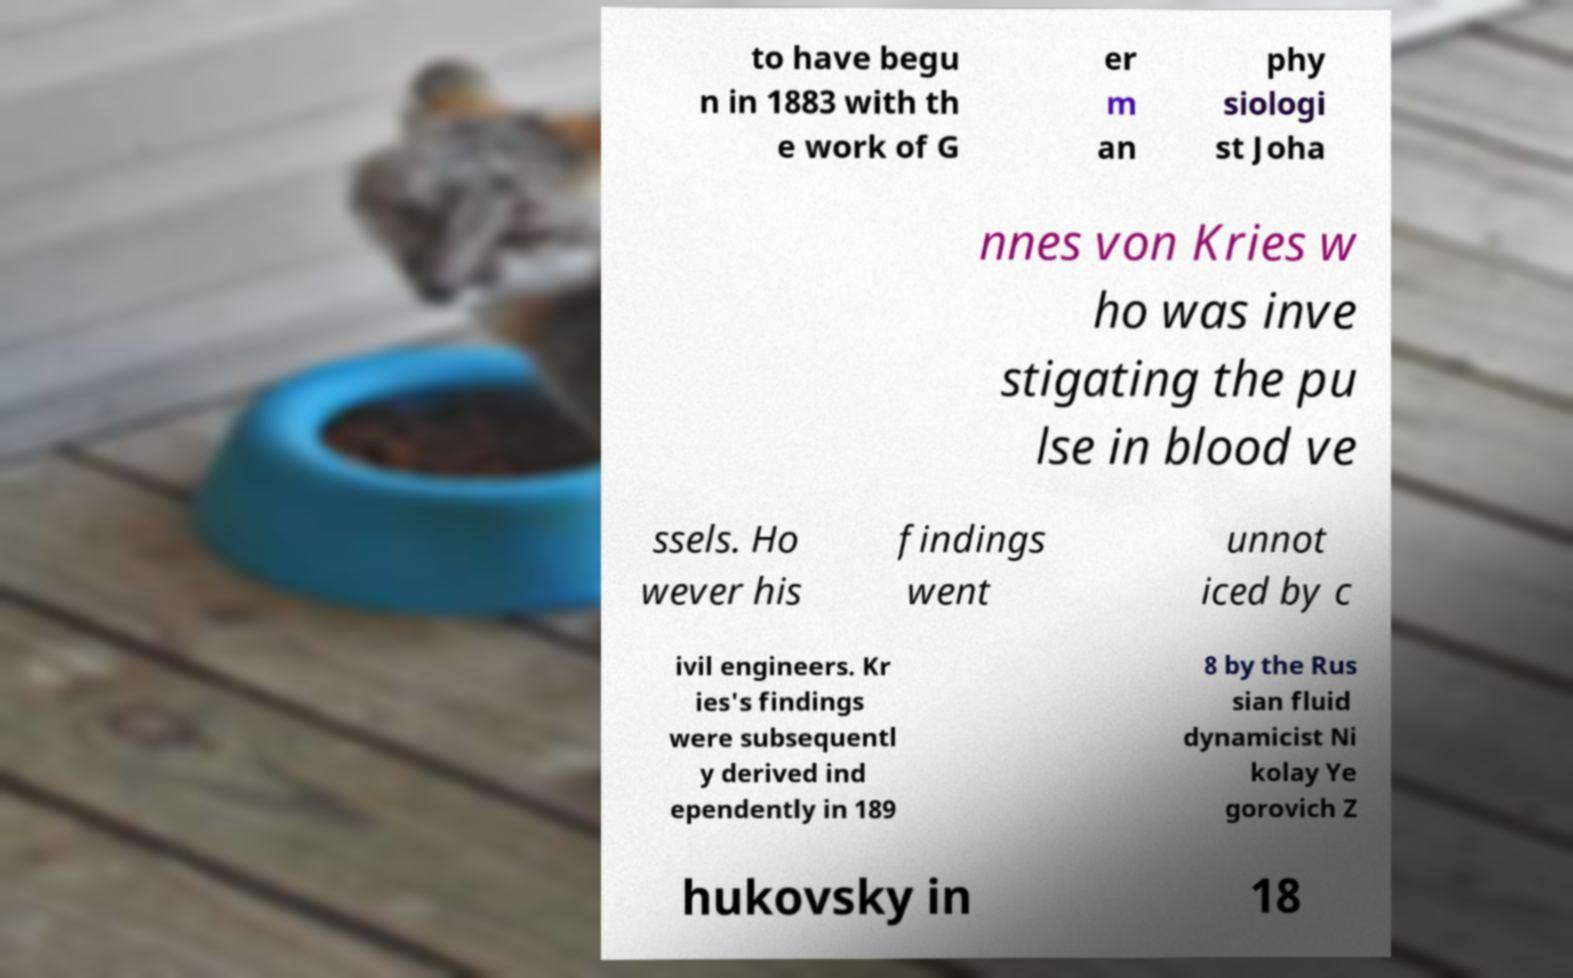Can you accurately transcribe the text from the provided image for me? to have begu n in 1883 with th e work of G er m an phy siologi st Joha nnes von Kries w ho was inve stigating the pu lse in blood ve ssels. Ho wever his findings went unnot iced by c ivil engineers. Kr ies's findings were subsequentl y derived ind ependently in 189 8 by the Rus sian fluid dynamicist Ni kolay Ye gorovich Z hukovsky in 18 